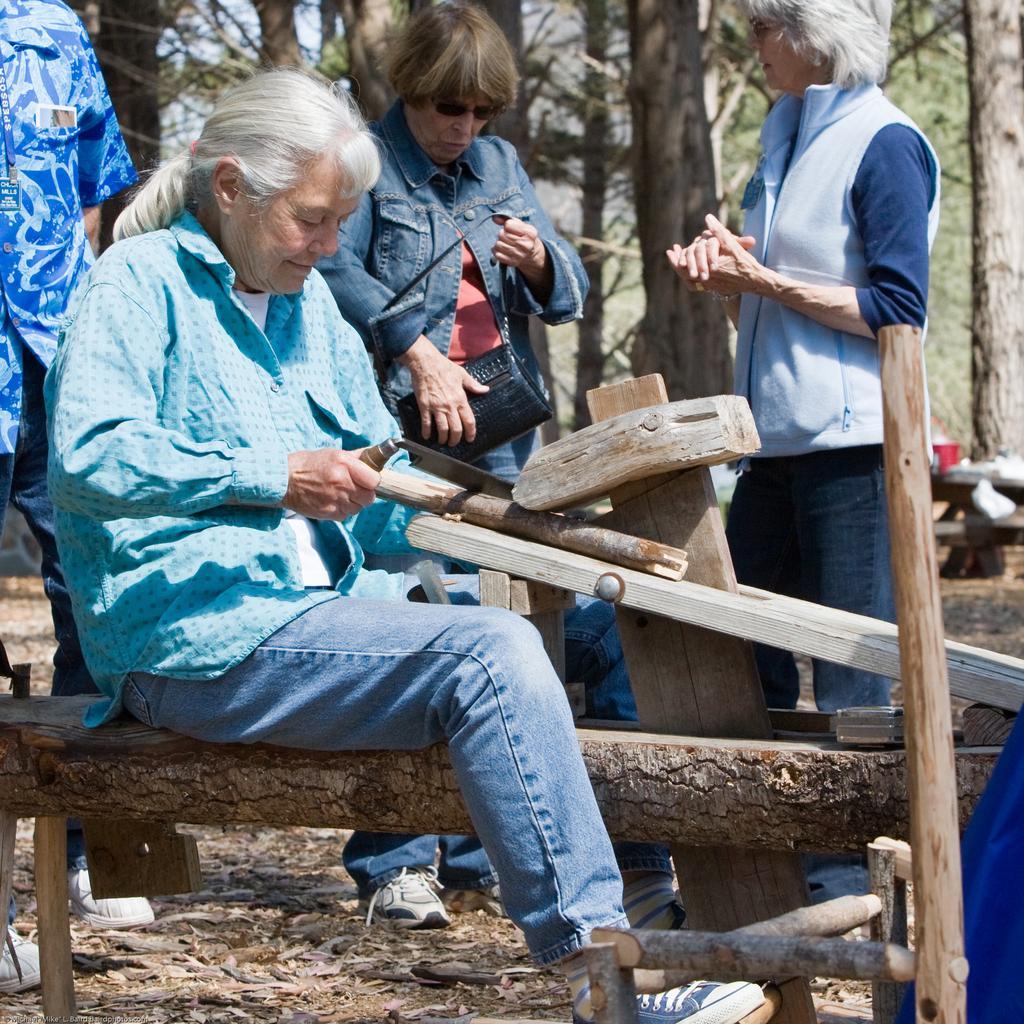Please provide a concise description of this image. In this image there is an old woman sitting on a trunk of wood, holding a hand saw is cutting a piece of wood, behind the woman there are three other people standing, behind them there are trees. 